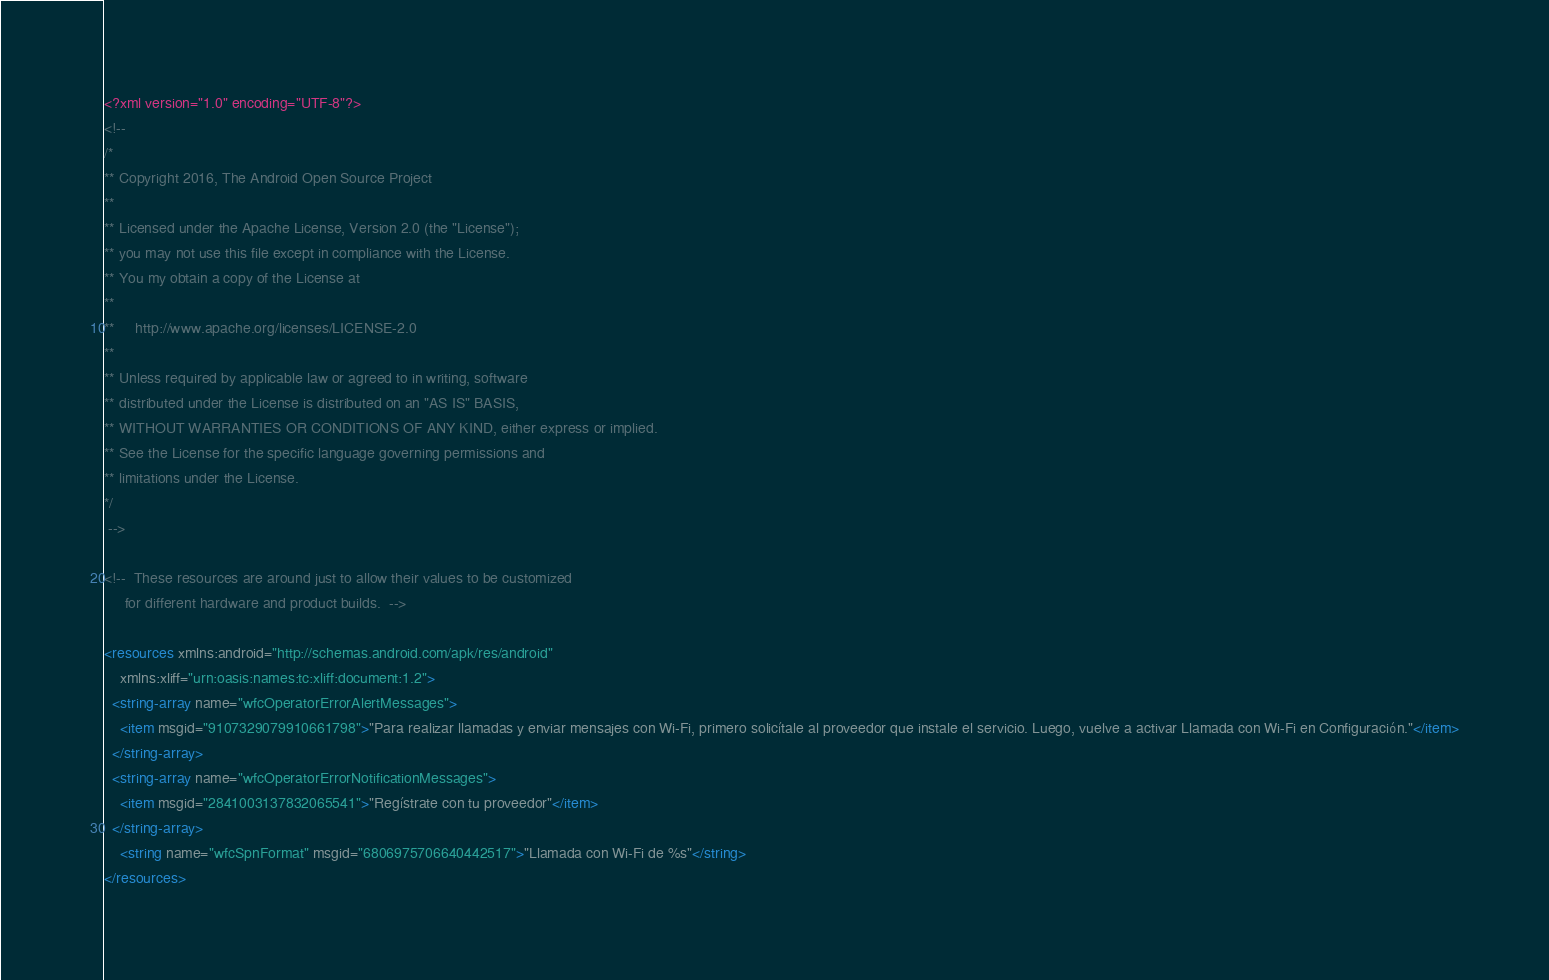Convert code to text. <code><loc_0><loc_0><loc_500><loc_500><_XML_><?xml version="1.0" encoding="UTF-8"?>
<!-- 
/*
** Copyright 2016, The Android Open Source Project
**
** Licensed under the Apache License, Version 2.0 (the "License");
** you may not use this file except in compliance with the License.
** You my obtain a copy of the License at
**
**     http://www.apache.org/licenses/LICENSE-2.0
**
** Unless required by applicable law or agreed to in writing, software
** distributed under the License is distributed on an "AS IS" BASIS,
** WITHOUT WARRANTIES OR CONDITIONS OF ANY KIND, either express or implied.
** See the License for the specific language governing permissions and
** limitations under the License.
*/
 -->

<!--  These resources are around just to allow their values to be customized
     for different hardware and product builds.  -->

<resources xmlns:android="http://schemas.android.com/apk/res/android"
    xmlns:xliff="urn:oasis:names:tc:xliff:document:1.2">
  <string-array name="wfcOperatorErrorAlertMessages">
    <item msgid="9107329079910661798">"Para realizar llamadas y enviar mensajes con Wi-Fi, primero solicítale al proveedor que instale el servicio. Luego, vuelve a activar Llamada con Wi-Fi en Configuración."</item>
  </string-array>
  <string-array name="wfcOperatorErrorNotificationMessages">
    <item msgid="2841003137832065541">"Regístrate con tu proveedor"</item>
  </string-array>
    <string name="wfcSpnFormat" msgid="6806975706640442517">"Llamada con Wi-Fi de %s"</string>
</resources>
</code> 